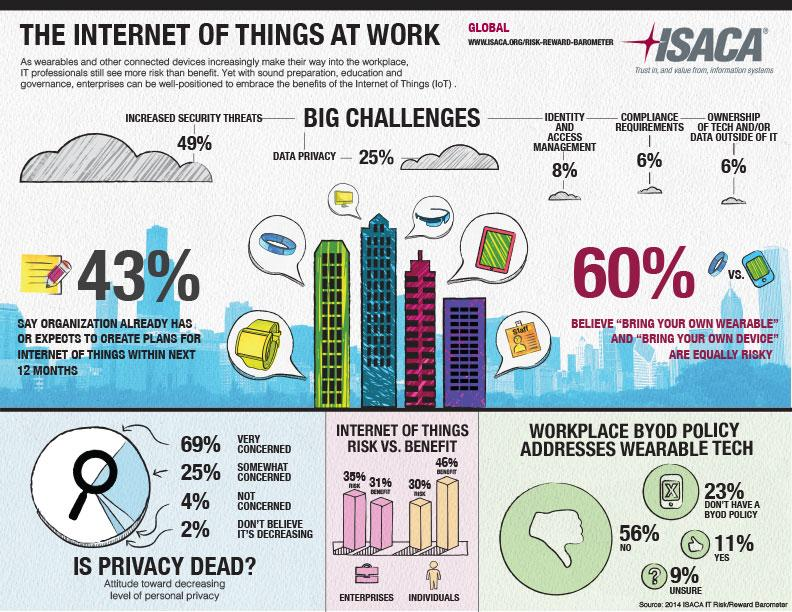Indicate a few pertinent items in this graphic. The percentage of increased security threats is 49%. According to the survey, 43% of organizations have already created plans for incorporating IoT within the next 12 months. According to a recent survey, only 6% of non-IT personnel have access to tech and/or data outside of their department. According to a study, the IoT risks in enterprises are estimated to be 35%. According to the information provided, 46% of the benefits derived from IoT were provided on an individual basis. 